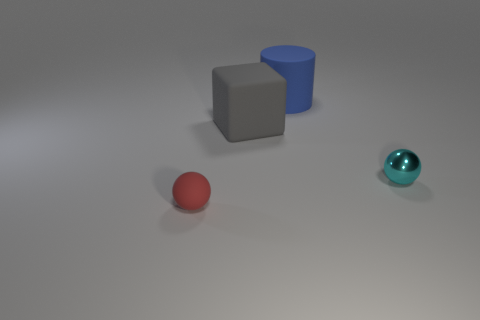Add 4 big cylinders. How many objects exist? 8 Subtract all large green matte cubes. Subtract all cubes. How many objects are left? 3 Add 1 small things. How many small things are left? 3 Add 4 red balls. How many red balls exist? 5 Subtract 0 purple balls. How many objects are left? 4 Subtract all cylinders. How many objects are left? 3 Subtract all green balls. Subtract all purple cubes. How many balls are left? 2 